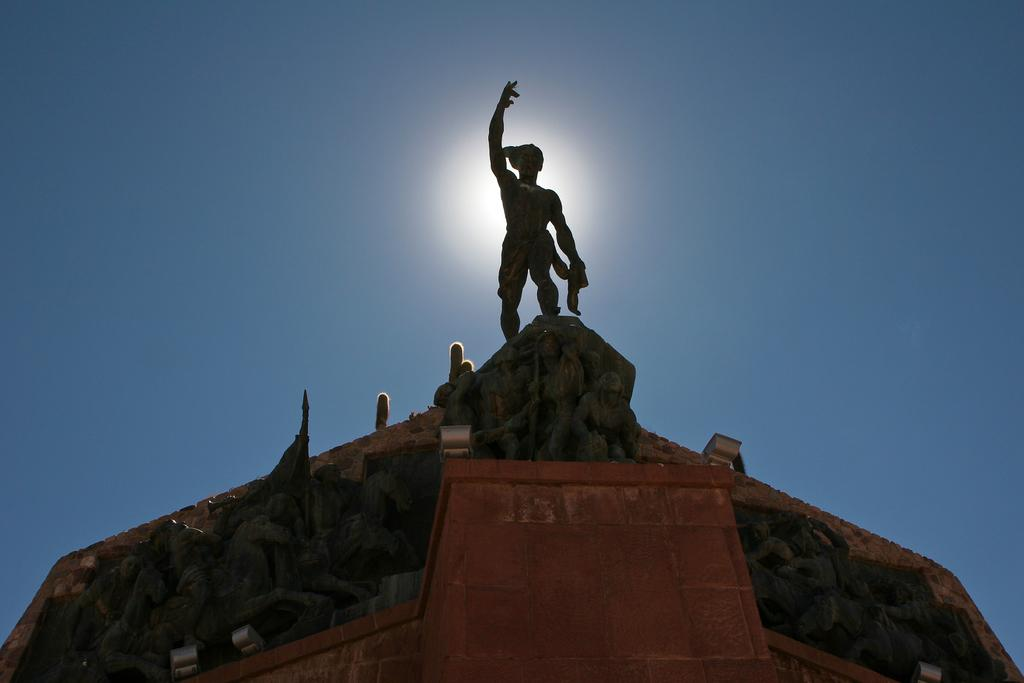What is the main subject of the image? There is a sculpture of a person in the image. What is the color of the sky in the image? The sky is pale blue in color. Can you describe any other objects or features in the image? There is a light in the image. How many friends are sitting on the books in the image? There are no friends or books present in the image. 